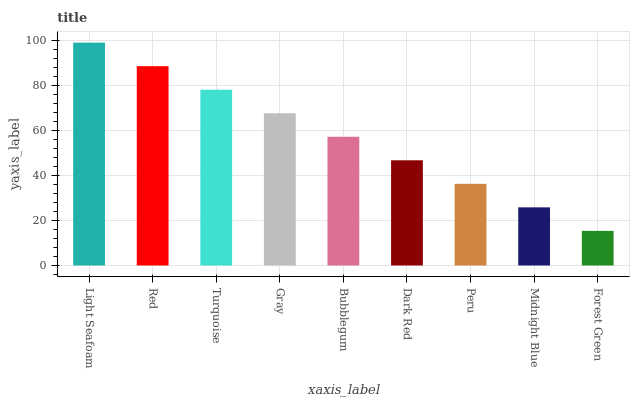Is Forest Green the minimum?
Answer yes or no. Yes. Is Light Seafoam the maximum?
Answer yes or no. Yes. Is Red the minimum?
Answer yes or no. No. Is Red the maximum?
Answer yes or no. No. Is Light Seafoam greater than Red?
Answer yes or no. Yes. Is Red less than Light Seafoam?
Answer yes or no. Yes. Is Red greater than Light Seafoam?
Answer yes or no. No. Is Light Seafoam less than Red?
Answer yes or no. No. Is Bubblegum the high median?
Answer yes or no. Yes. Is Bubblegum the low median?
Answer yes or no. Yes. Is Red the high median?
Answer yes or no. No. Is Midnight Blue the low median?
Answer yes or no. No. 